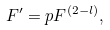Convert formula to latex. <formula><loc_0><loc_0><loc_500><loc_500>F ^ { \prime } = p F ^ { ( 2 - l ) } ,</formula> 